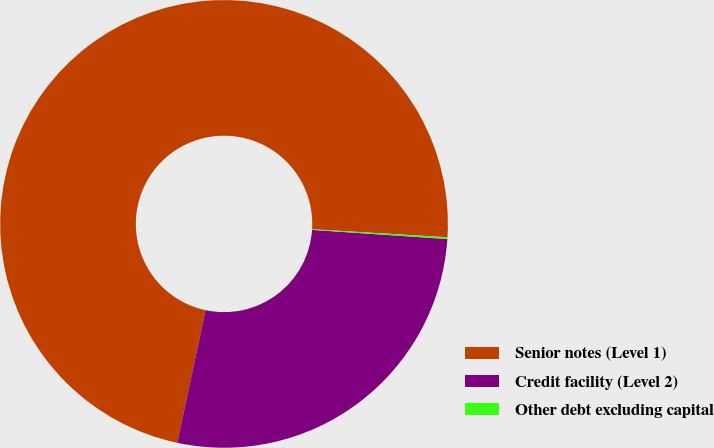Convert chart. <chart><loc_0><loc_0><loc_500><loc_500><pie_chart><fcel>Senior notes (Level 1)<fcel>Credit facility (Level 2)<fcel>Other debt excluding capital<nl><fcel>72.6%<fcel>27.28%<fcel>0.13%<nl></chart> 